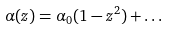Convert formula to latex. <formula><loc_0><loc_0><loc_500><loc_500>\alpha ( z ) = \alpha _ { 0 } ( 1 - z ^ { 2 } ) + \dots</formula> 